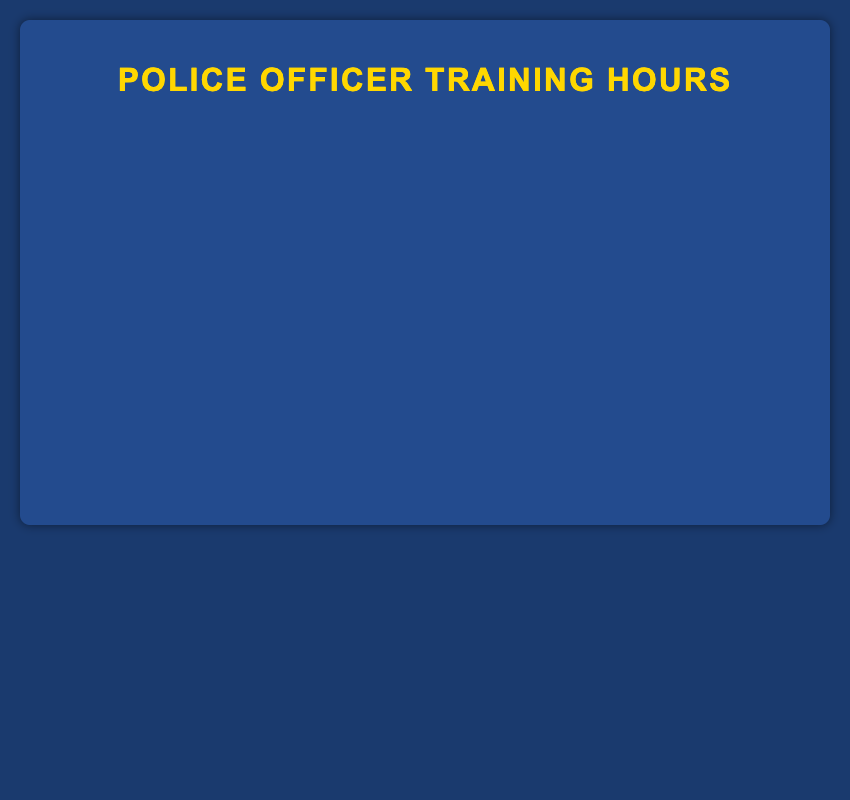Which training type required the most hours? Identify the bar with the maximum length. "Emergency Vehicle Operations" has the longest bar at 40 hours.
Answer: Emergency Vehicle Operations Which two training types have the fewest hours combined? Find the two bars with the shortest lengths, "First Aid and CPR" (15 hours) and "Crisis Intervention Training" (18 hours), and add them: 15 + 18 = 33 hours.
Answer: First Aid and CPR, Crisis Intervention Training By how many hours does "Firearm Handling and Safety" exceed "Community Policing"? Subtract the length of the "Community Policing" bar (20 hours) from the "Firearm Handling and Safety" bar (35 hours): 35 - 20 = 15 hours.
Answer: 15 hours What's the average number of training hours across all types? Sum all the training hours and divide by the number of training types: (35 + 25 + 40 + 30 + 20 + 15 + 18 + 22 + 28) / 9 = 26.11 hours.
Answer: 26.11 hours Are there more training hours spent on "Legal Updates and Procedures" or "Drug Recognition Expert (DRE) Training"? Compare the lengths of "Legal Updates and Procedures" (22 hours) and "Drug Recognition Expert (DRE) Training" (28 hours). 28 > 22, so "Drug Recognition Expert (DRE) Training" has more hours.
Answer: Drug Recognition Expert (DRE) Training What is the total number of training hours completed for "Self-Defense Tactics," "Criminal Investigation Techniques," and "First Aid and CPR"? Add the hours: "Self-Defense Tactics" (25) + "Criminal Investigation Techniques" (30) + "First Aid and CPR" (15) = 25 + 30 + 15 = 70 hours.
Answer: 70 hours Which training type uses a green-colored bar? Identify the color associated with "green." The "Community Policing" bar appears in green.
Answer: Community Policing How many more hours are dedicated to "Self-Defense Tactics" compared to "First Aid and CPR"? Subtract the hours of "First Aid and CPR" (15) from "Self-Defense Tactics" (25): 25 - 15 = 10 hours.
Answer: 10 hours What percentage of the total training hours is dedicated to "Criminal Investigation Techniques"? Calculate the percentage: (30 / total hours) * 100. Total hours = 233. (30 / 233) * 100 ≈ 12.88%.
Answer: 12.88% 